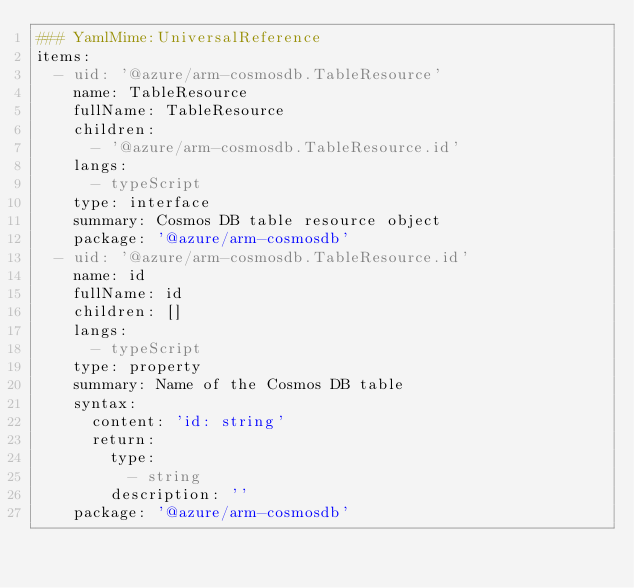<code> <loc_0><loc_0><loc_500><loc_500><_YAML_>### YamlMime:UniversalReference
items:
  - uid: '@azure/arm-cosmosdb.TableResource'
    name: TableResource
    fullName: TableResource
    children:
      - '@azure/arm-cosmosdb.TableResource.id'
    langs:
      - typeScript
    type: interface
    summary: Cosmos DB table resource object
    package: '@azure/arm-cosmosdb'
  - uid: '@azure/arm-cosmosdb.TableResource.id'
    name: id
    fullName: id
    children: []
    langs:
      - typeScript
    type: property
    summary: Name of the Cosmos DB table
    syntax:
      content: 'id: string'
      return:
        type:
          - string
        description: ''
    package: '@azure/arm-cosmosdb'
</code> 